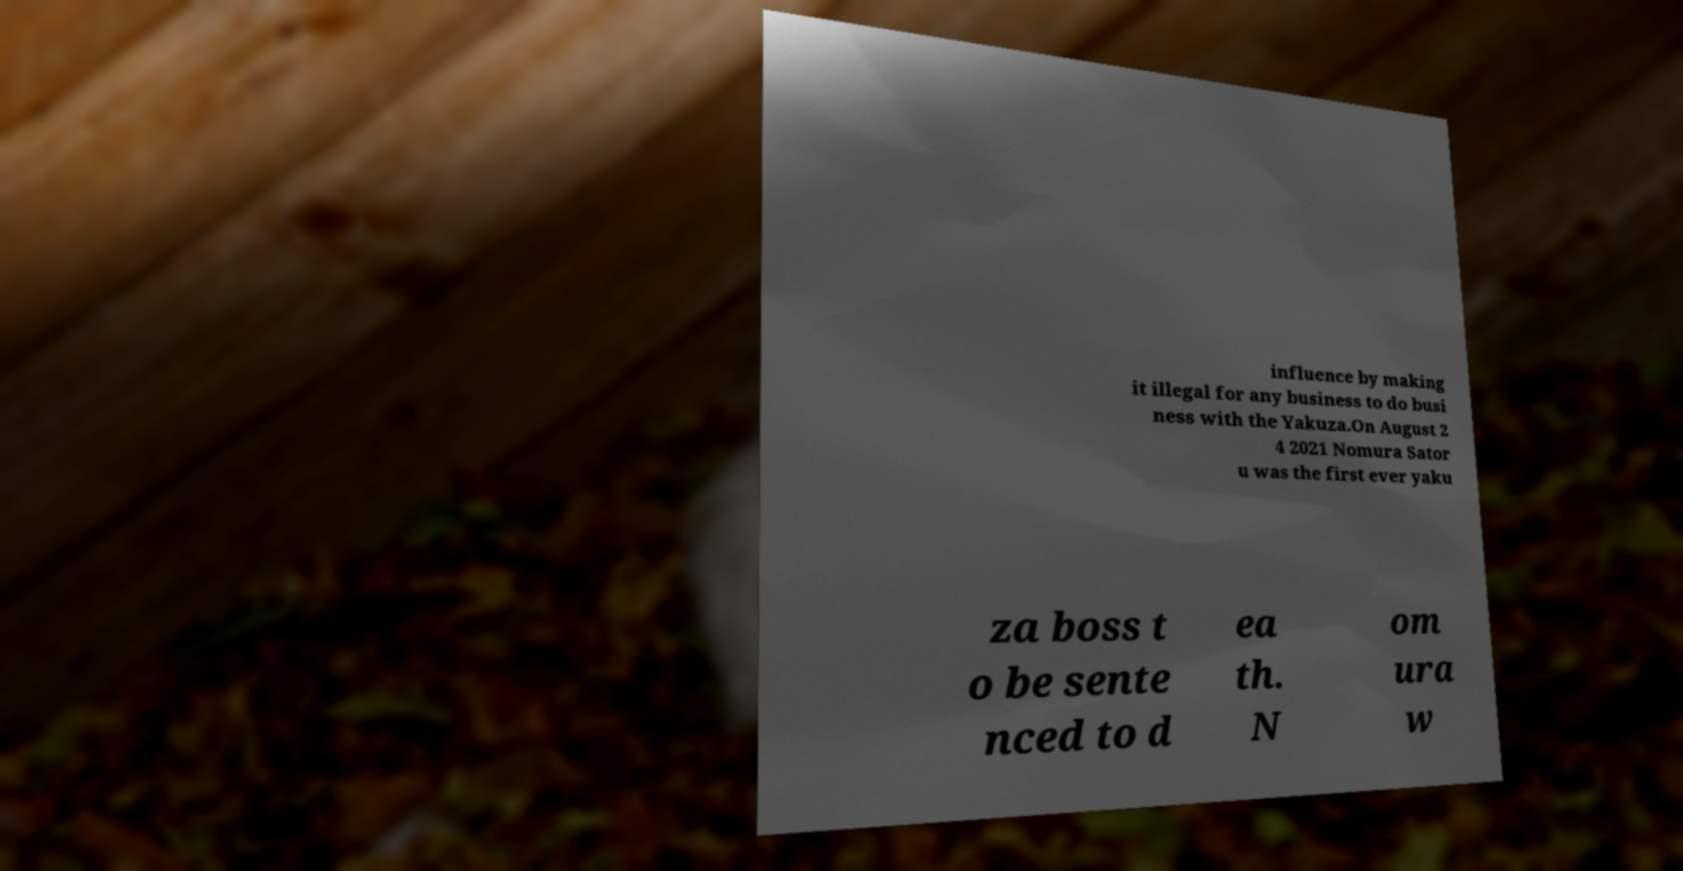Could you extract and type out the text from this image? influence by making it illegal for any business to do busi ness with the Yakuza.On August 2 4 2021 Nomura Sator u was the first ever yaku za boss t o be sente nced to d ea th. N om ura w 